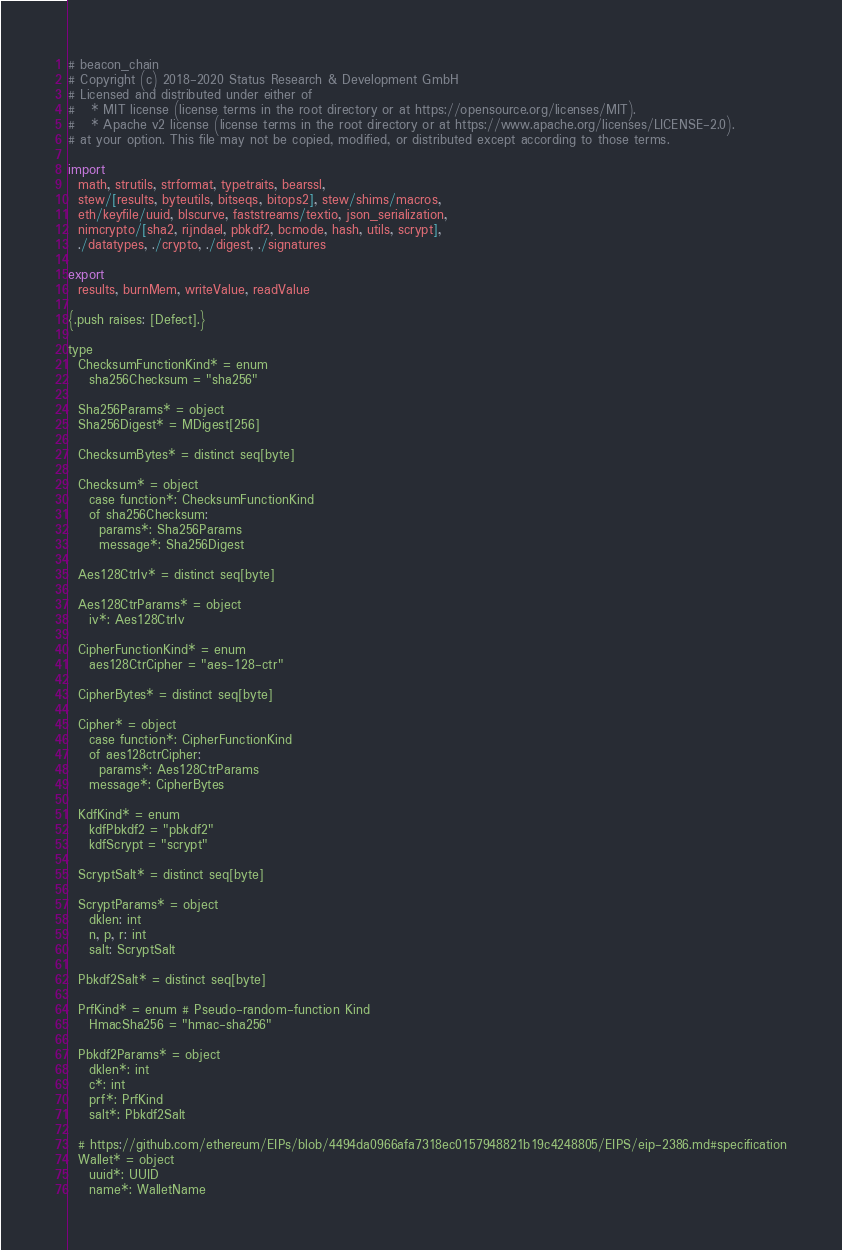Convert code to text. <code><loc_0><loc_0><loc_500><loc_500><_Nim_># beacon_chain
# Copyright (c) 2018-2020 Status Research & Development GmbH
# Licensed and distributed under either of
#   * MIT license (license terms in the root directory or at https://opensource.org/licenses/MIT).
#   * Apache v2 license (license terms in the root directory or at https://www.apache.org/licenses/LICENSE-2.0).
# at your option. This file may not be copied, modified, or distributed except according to those terms.

import
  math, strutils, strformat, typetraits, bearssl,
  stew/[results, byteutils, bitseqs, bitops2], stew/shims/macros,
  eth/keyfile/uuid, blscurve, faststreams/textio, json_serialization,
  nimcrypto/[sha2, rijndael, pbkdf2, bcmode, hash, utils, scrypt],
  ./datatypes, ./crypto, ./digest, ./signatures

export
  results, burnMem, writeValue, readValue

{.push raises: [Defect].}

type
  ChecksumFunctionKind* = enum
    sha256Checksum = "sha256"

  Sha256Params* = object
  Sha256Digest* = MDigest[256]

  ChecksumBytes* = distinct seq[byte]

  Checksum* = object
    case function*: ChecksumFunctionKind
    of sha256Checksum:
      params*: Sha256Params
      message*: Sha256Digest

  Aes128CtrIv* = distinct seq[byte]

  Aes128CtrParams* = object
    iv*: Aes128CtrIv

  CipherFunctionKind* = enum
    aes128CtrCipher = "aes-128-ctr"

  CipherBytes* = distinct seq[byte]

  Cipher* = object
    case function*: CipherFunctionKind
    of aes128ctrCipher:
      params*: Aes128CtrParams
    message*: CipherBytes

  KdfKind* = enum
    kdfPbkdf2 = "pbkdf2"
    kdfScrypt = "scrypt"

  ScryptSalt* = distinct seq[byte]

  ScryptParams* = object
    dklen: int
    n, p, r: int
    salt: ScryptSalt

  Pbkdf2Salt* = distinct seq[byte]

  PrfKind* = enum # Pseudo-random-function Kind
    HmacSha256 = "hmac-sha256"

  Pbkdf2Params* = object
    dklen*: int
    c*: int
    prf*: PrfKind
    salt*: Pbkdf2Salt

  # https://github.com/ethereum/EIPs/blob/4494da0966afa7318ec0157948821b19c4248805/EIPS/eip-2386.md#specification
  Wallet* = object
    uuid*: UUID
    name*: WalletName</code> 